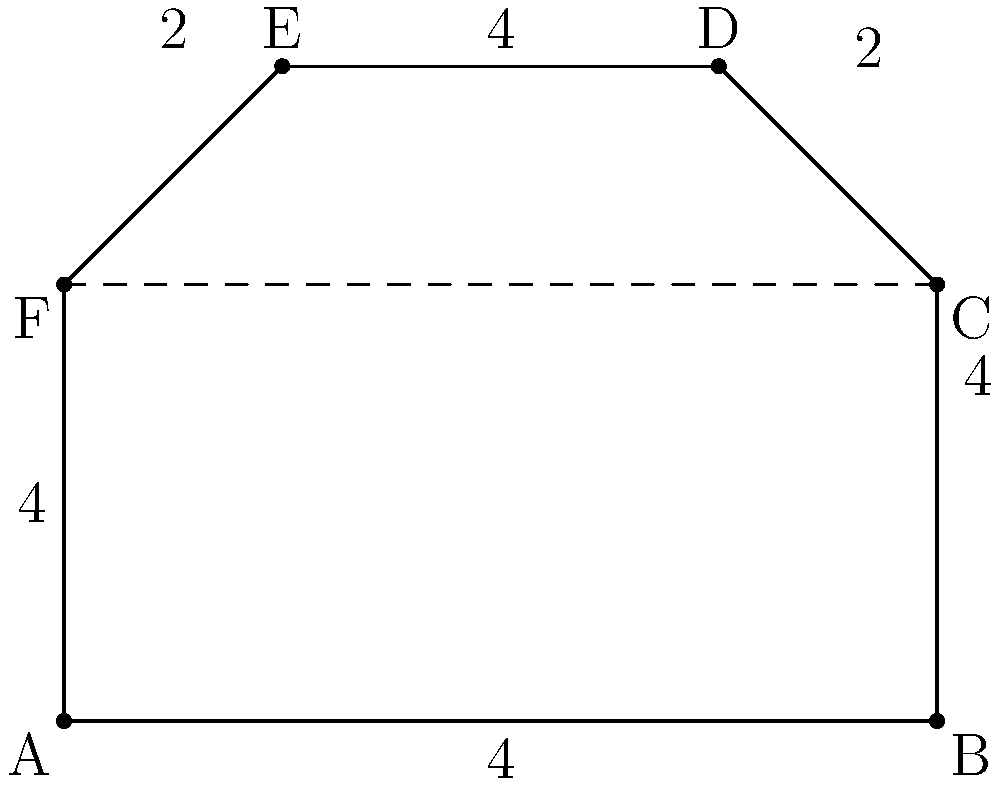As a hotel staff member recommending tours, you're often asked about the size of the popular Starlight Park. The park has an irregular shape as shown in the diagram. If the smallest square on the grid represents 1 square kilometer, what is the total area of Starlight Park in square kilometers? To find the area of this irregular shape, we can break it down into simpler geometric shapes:

1. First, divide the park into a rectangle (ABCF) and a trapezoid (CDEF).

2. Calculate the area of the rectangle ABCF:
   Length = 8 km, Width = 4 km
   Area of rectangle = $8 \times 4 = 32$ sq km

3. Calculate the area of the trapezoid CDEF:
   Base 1 (CF) = 8 km
   Base 2 (DE) = 4 km
   Height = 2 km
   Area of trapezoid = $\frac{1}{2}(8 + 4) \times 2 = 12$ sq km

4. Sum up the areas:
   Total Area = Area of rectangle + Area of trapezoid
               = $32 + 12 = 44$ sq km

Therefore, the total area of Starlight Park is 44 square kilometers.
Answer: 44 square kilometers 